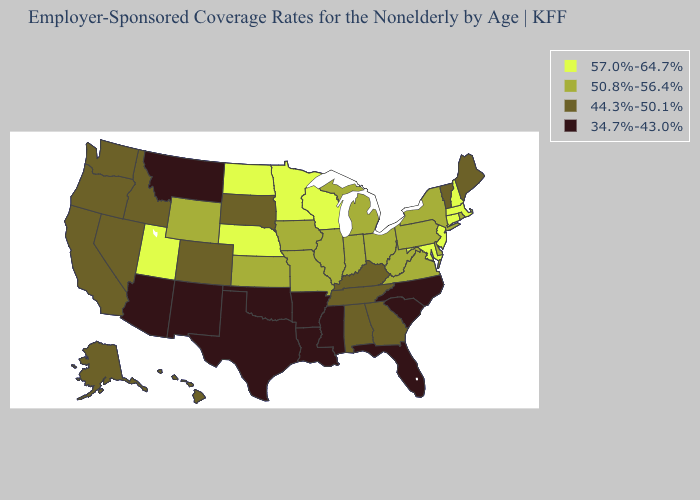What is the value of California?
Be succinct. 44.3%-50.1%. What is the lowest value in the Northeast?
Quick response, please. 44.3%-50.1%. Does South Dakota have the lowest value in the MidWest?
Concise answer only. Yes. What is the value of Minnesota?
Be succinct. 57.0%-64.7%. Name the states that have a value in the range 34.7%-43.0%?
Be succinct. Arizona, Arkansas, Florida, Louisiana, Mississippi, Montana, New Mexico, North Carolina, Oklahoma, South Carolina, Texas. What is the lowest value in the MidWest?
Short answer required. 44.3%-50.1%. What is the value of Virginia?
Short answer required. 50.8%-56.4%. Name the states that have a value in the range 50.8%-56.4%?
Give a very brief answer. Delaware, Illinois, Indiana, Iowa, Kansas, Michigan, Missouri, New York, Ohio, Pennsylvania, Rhode Island, Virginia, West Virginia, Wyoming. What is the highest value in the West ?
Concise answer only. 57.0%-64.7%. How many symbols are there in the legend?
Answer briefly. 4. Which states have the highest value in the USA?
Write a very short answer. Connecticut, Maryland, Massachusetts, Minnesota, Nebraska, New Hampshire, New Jersey, North Dakota, Utah, Wisconsin. Which states have the highest value in the USA?
Keep it brief. Connecticut, Maryland, Massachusetts, Minnesota, Nebraska, New Hampshire, New Jersey, North Dakota, Utah, Wisconsin. What is the value of South Carolina?
Short answer required. 34.7%-43.0%. What is the value of Indiana?
Be succinct. 50.8%-56.4%. What is the value of Nevada?
Quick response, please. 44.3%-50.1%. 